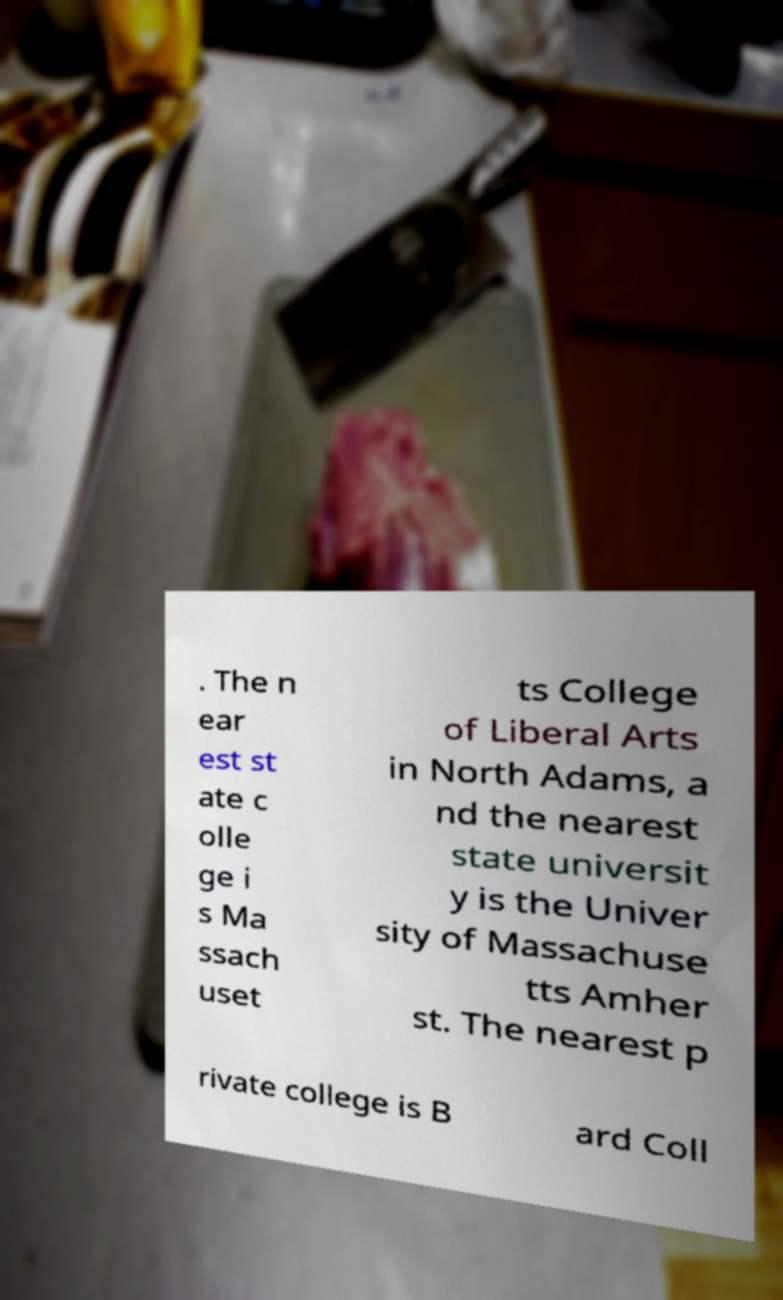Please read and relay the text visible in this image. What does it say? . The n ear est st ate c olle ge i s Ma ssach uset ts College of Liberal Arts in North Adams, a nd the nearest state universit y is the Univer sity of Massachuse tts Amher st. The nearest p rivate college is B ard Coll 